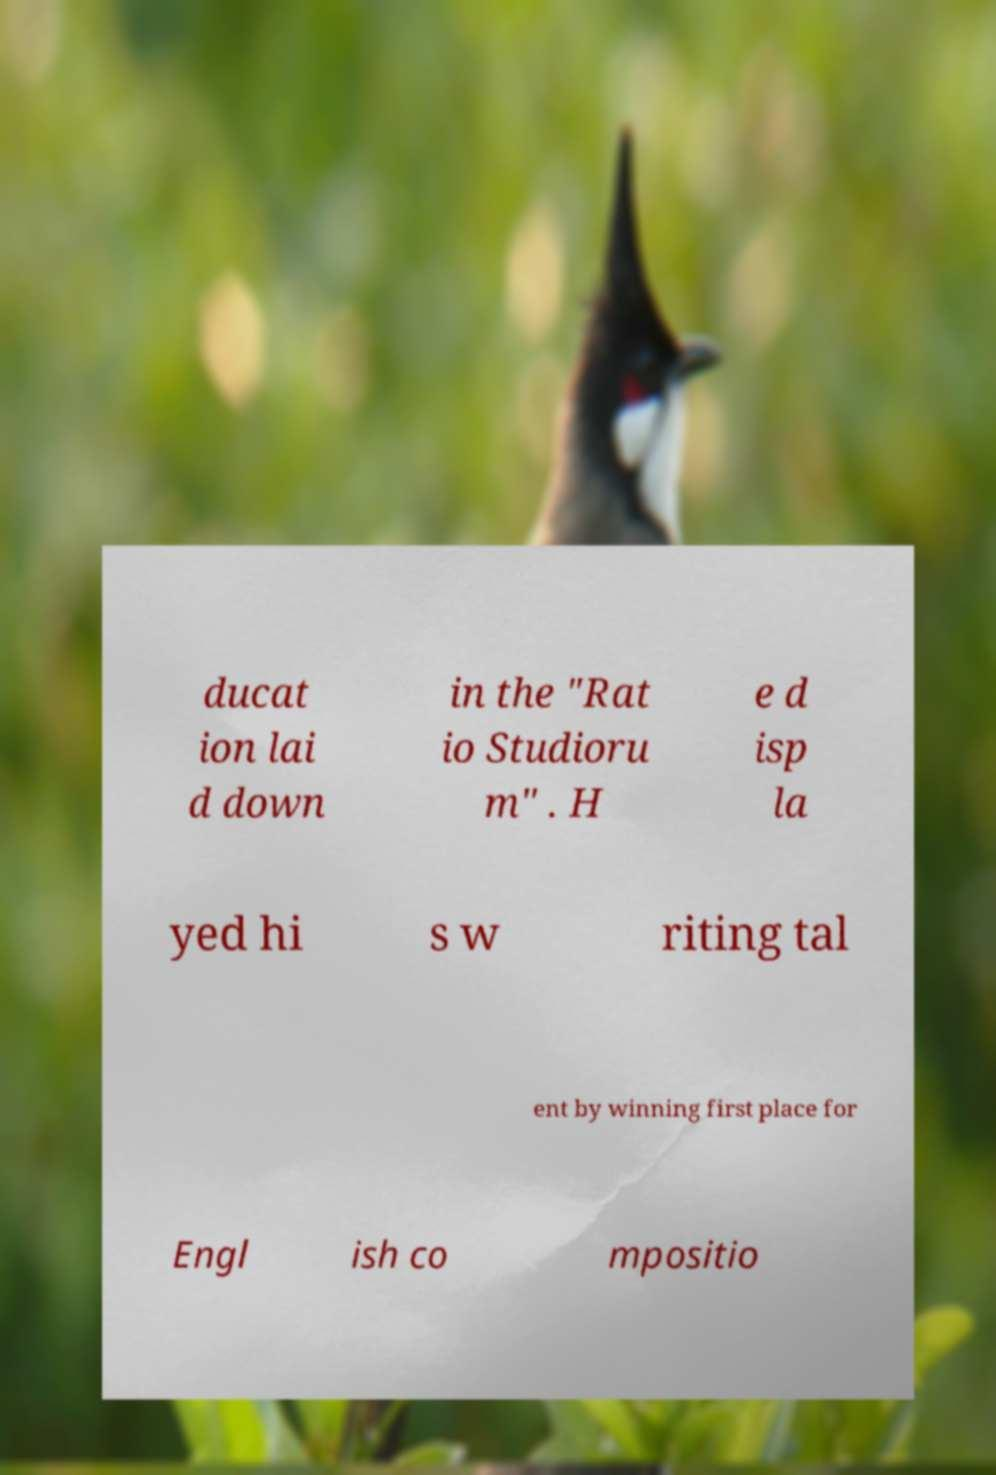Could you assist in decoding the text presented in this image and type it out clearly? ducat ion lai d down in the "Rat io Studioru m" . H e d isp la yed hi s w riting tal ent by winning first place for Engl ish co mpositio 